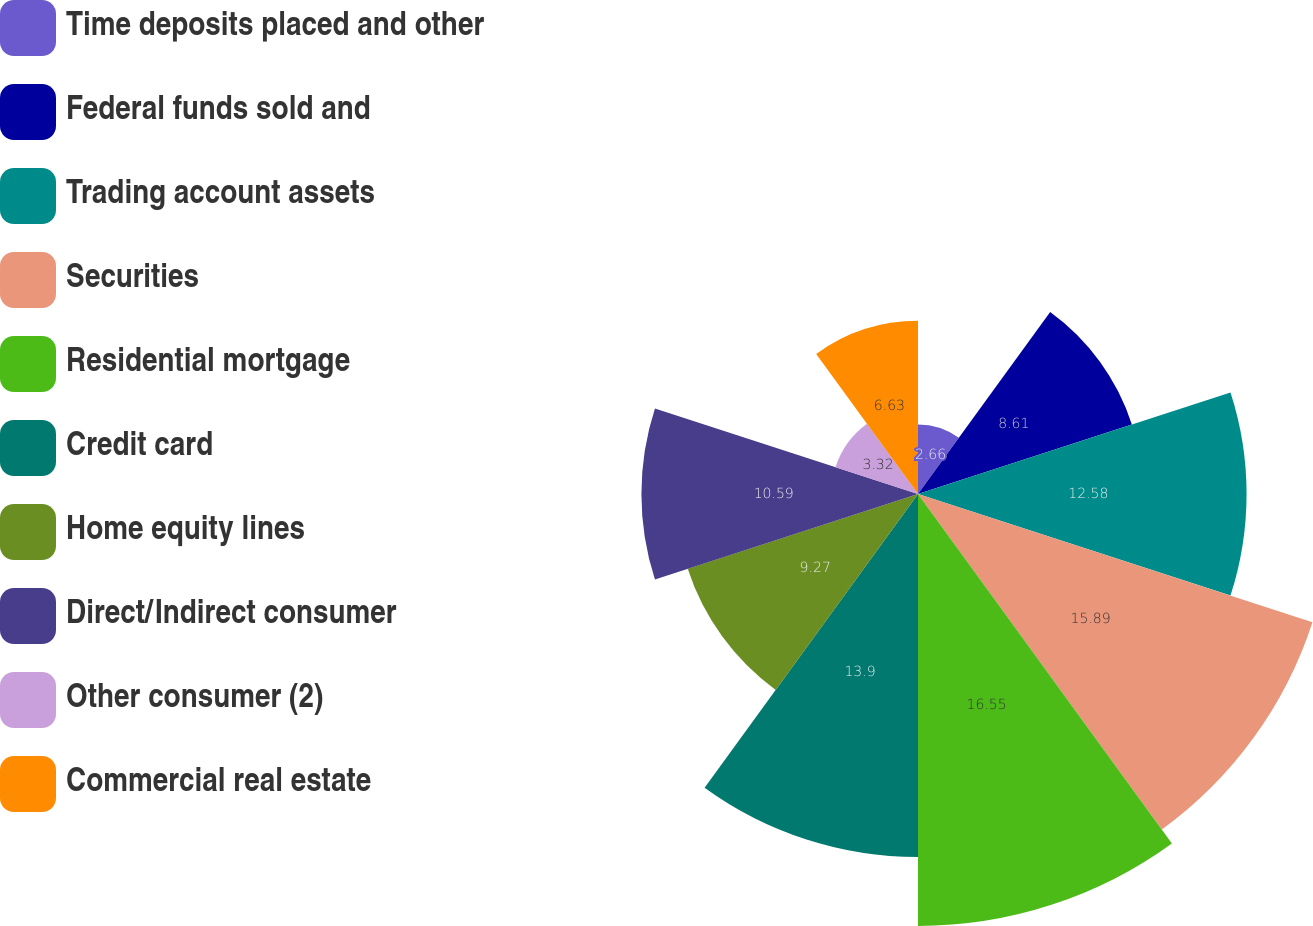Convert chart to OTSL. <chart><loc_0><loc_0><loc_500><loc_500><pie_chart><fcel>Time deposits placed and other<fcel>Federal funds sold and<fcel>Trading account assets<fcel>Securities<fcel>Residential mortgage<fcel>Credit card<fcel>Home equity lines<fcel>Direct/Indirect consumer<fcel>Other consumer (2)<fcel>Commercial real estate<nl><fcel>2.66%<fcel>8.61%<fcel>12.58%<fcel>15.88%<fcel>16.54%<fcel>13.9%<fcel>9.27%<fcel>10.59%<fcel>3.32%<fcel>6.63%<nl></chart> 